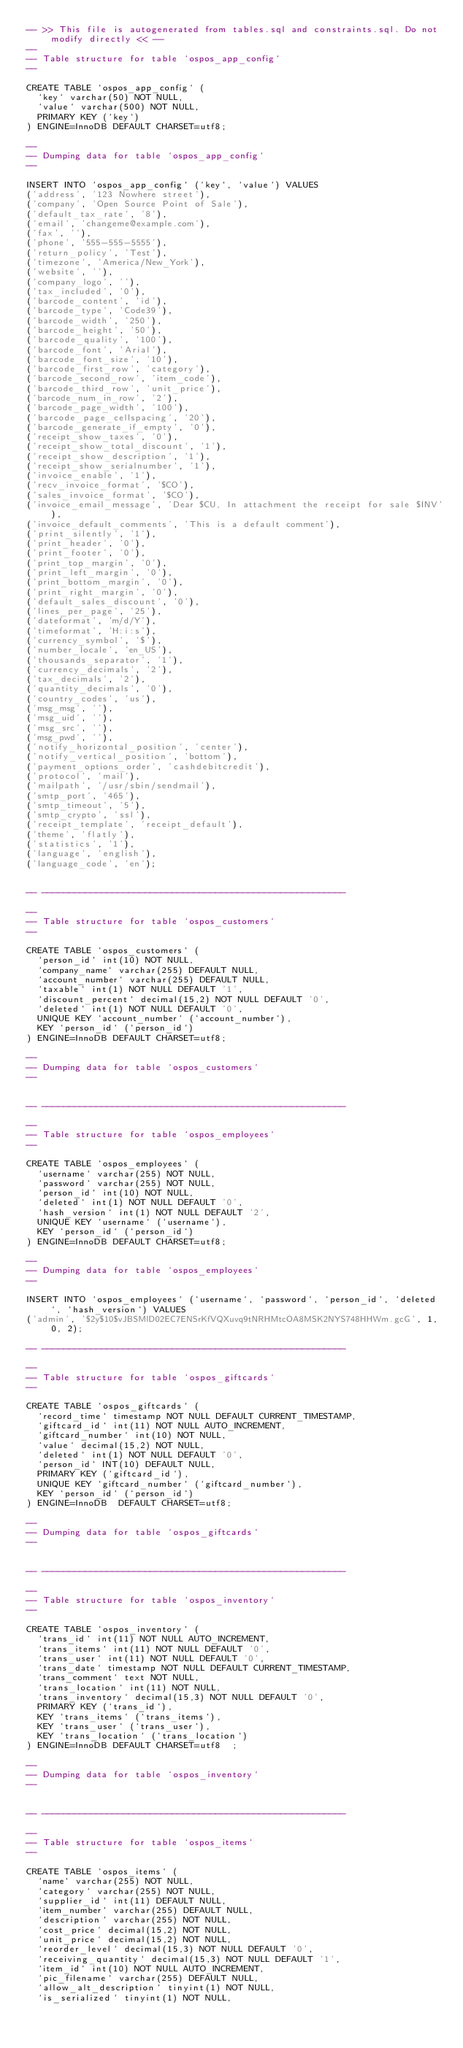<code> <loc_0><loc_0><loc_500><loc_500><_SQL_>-- >> This file is autogenerated from tables.sql and constraints.sql. Do not modify directly << --
--
-- Table structure for table `ospos_app_config`
--

CREATE TABLE `ospos_app_config` (
  `key` varchar(50) NOT NULL,
  `value` varchar(500) NOT NULL,
  PRIMARY KEY (`key`)
) ENGINE=InnoDB DEFAULT CHARSET=utf8;

--
-- Dumping data for table `ospos_app_config`
--

INSERT INTO `ospos_app_config` (`key`, `value`) VALUES
('address', '123 Nowhere street'),
('company', 'Open Source Point of Sale'),
('default_tax_rate', '8'),
('email', 'changeme@example.com'),
('fax', ''),
('phone', '555-555-5555'),
('return_policy', 'Test'),
('timezone', 'America/New_York'),
('website', ''),
('company_logo', ''),
('tax_included', '0'),
('barcode_content', 'id'),
('barcode_type', 'Code39'),
('barcode_width', '250'),
('barcode_height', '50'),
('barcode_quality', '100'),
('barcode_font', 'Arial'),
('barcode_font_size', '10'),
('barcode_first_row', 'category'),
('barcode_second_row', 'item_code'),
('barcode_third_row', 'unit_price'),
('barcode_num_in_row', '2'),
('barcode_page_width', '100'),      
('barcode_page_cellspacing', '20'),
('barcode_generate_if_empty', '0'),
('receipt_show_taxes', '0'),
('receipt_show_total_discount', '1'),
('receipt_show_description', '1'),
('receipt_show_serialnumber', '1'),
('invoice_enable', '1'),
('recv_invoice_format', '$CO'),
('sales_invoice_format', '$CO'),
('invoice_email_message', 'Dear $CU, In attachment the receipt for sale $INV'),
('invoice_default_comments', 'This is a default comment'),
('print_silently', '1'),
('print_header', '0'),
('print_footer', '0'),
('print_top_margin', '0'),
('print_left_margin', '0'),
('print_bottom_margin', '0'),
('print_right_margin', '0'),
('default_sales_discount', '0'),
('lines_per_page', '25'),
('dateformat', 'm/d/Y'),
('timeformat', 'H:i:s'),
('currency_symbol', '$'),
('number_locale', 'en_US'),
('thousands_separator', '1'),
('currency_decimals', '2'),
('tax_decimals', '2'),
('quantity_decimals', '0'),
('country_codes', 'us'),
('msg_msg', ''),
('msg_uid', ''),
('msg_src', ''),
('msg_pwd', ''),
('notify_horizontal_position', 'center'),
('notify_vertical_position', 'bottom'),
('payment_options_order', 'cashdebitcredit'),
('protocol', 'mail'),
('mailpath', '/usr/sbin/sendmail'),
('smtp_port', '465'),
('smtp_timeout', '5'),
('smtp_crypto', 'ssl'),
('receipt_template', 'receipt_default'),
('theme', 'flatly'),
('statistics', '1'),
('language', 'english'),
('language_code', 'en');


-- --------------------------------------------------------

--
-- Table structure for table `ospos_customers`
--

CREATE TABLE `ospos_customers` (
  `person_id` int(10) NOT NULL,
  `company_name` varchar(255) DEFAULT NULL,
  `account_number` varchar(255) DEFAULT NULL,
  `taxable` int(1) NOT NULL DEFAULT '1',
  `discount_percent` decimal(15,2) NOT NULL DEFAULT '0',
  `deleted` int(1) NOT NULL DEFAULT '0',
  UNIQUE KEY `account_number` (`account_number`),
  KEY `person_id` (`person_id`)
) ENGINE=InnoDB DEFAULT CHARSET=utf8;

--
-- Dumping data for table `ospos_customers`
--


-- --------------------------------------------------------

--
-- Table structure for table `ospos_employees`
--

CREATE TABLE `ospos_employees` (
  `username` varchar(255) NOT NULL,
  `password` varchar(255) NOT NULL,
  `person_id` int(10) NOT NULL,
  `deleted` int(1) NOT NULL DEFAULT '0',
  `hash_version` int(1) NOT NULL DEFAULT '2',
  UNIQUE KEY `username` (`username`),
  KEY `person_id` (`person_id`)
) ENGINE=InnoDB DEFAULT CHARSET=utf8;

--
-- Dumping data for table `ospos_employees`
--

INSERT INTO `ospos_employees` (`username`, `password`, `person_id`, `deleted`, `hash_version`) VALUES
('admin', '$2y$10$vJBSMlD02EC7ENSrKfVQXuvq9tNRHMtcOA8MSK2NYS748HHWm.gcG', 1, 0, 2);

-- --------------------------------------------------------

--
-- Table structure for table `ospos_giftcards`
--

CREATE TABLE `ospos_giftcards` (
  `record_time` timestamp NOT NULL DEFAULT CURRENT_TIMESTAMP,
  `giftcard_id` int(11) NOT NULL AUTO_INCREMENT,
  `giftcard_number` int(10) NOT NULL,
  `value` decimal(15,2) NOT NULL,
  `deleted` int(1) NOT NULL DEFAULT '0',
  `person_id` INT(10) DEFAULT NULL,
  PRIMARY KEY (`giftcard_id`),
  UNIQUE KEY `giftcard_number` (`giftcard_number`),
  KEY `person_id` (`person_id`)
) ENGINE=InnoDB  DEFAULT CHARSET=utf8;

--
-- Dumping data for table `ospos_giftcards`
--


-- --------------------------------------------------------

--
-- Table structure for table `ospos_inventory`
--

CREATE TABLE `ospos_inventory` (
  `trans_id` int(11) NOT NULL AUTO_INCREMENT,
  `trans_items` int(11) NOT NULL DEFAULT '0',
  `trans_user` int(11) NOT NULL DEFAULT '0',
  `trans_date` timestamp NOT NULL DEFAULT CURRENT_TIMESTAMP,
  `trans_comment` text NOT NULL,
  `trans_location` int(11) NOT NULL,
  `trans_inventory` decimal(15,3) NOT NULL DEFAULT '0',
  PRIMARY KEY (`trans_id`),
  KEY `trans_items` (`trans_items`),
  KEY `trans_user` (`trans_user`),
  KEY `trans_location` (`trans_location`)
) ENGINE=InnoDB DEFAULT CHARSET=utf8  ;

--
-- Dumping data for table `ospos_inventory`
--


-- --------------------------------------------------------

--
-- Table structure for table `ospos_items`
--

CREATE TABLE `ospos_items` (
  `name` varchar(255) NOT NULL,
  `category` varchar(255) NOT NULL,
  `supplier_id` int(11) DEFAULT NULL,
  `item_number` varchar(255) DEFAULT NULL,
  `description` varchar(255) NOT NULL,
  `cost_price` decimal(15,2) NOT NULL,
  `unit_price` decimal(15,2) NOT NULL,
  `reorder_level` decimal(15,3) NOT NULL DEFAULT '0',
  `receiving_quantity` decimal(15,3) NOT NULL DEFAULT '1',
  `item_id` int(10) NOT NULL AUTO_INCREMENT,
  `pic_filename` varchar(255) DEFAULT NULL,
  `allow_alt_description` tinyint(1) NOT NULL,
  `is_serialized` tinyint(1) NOT NULL,</code> 